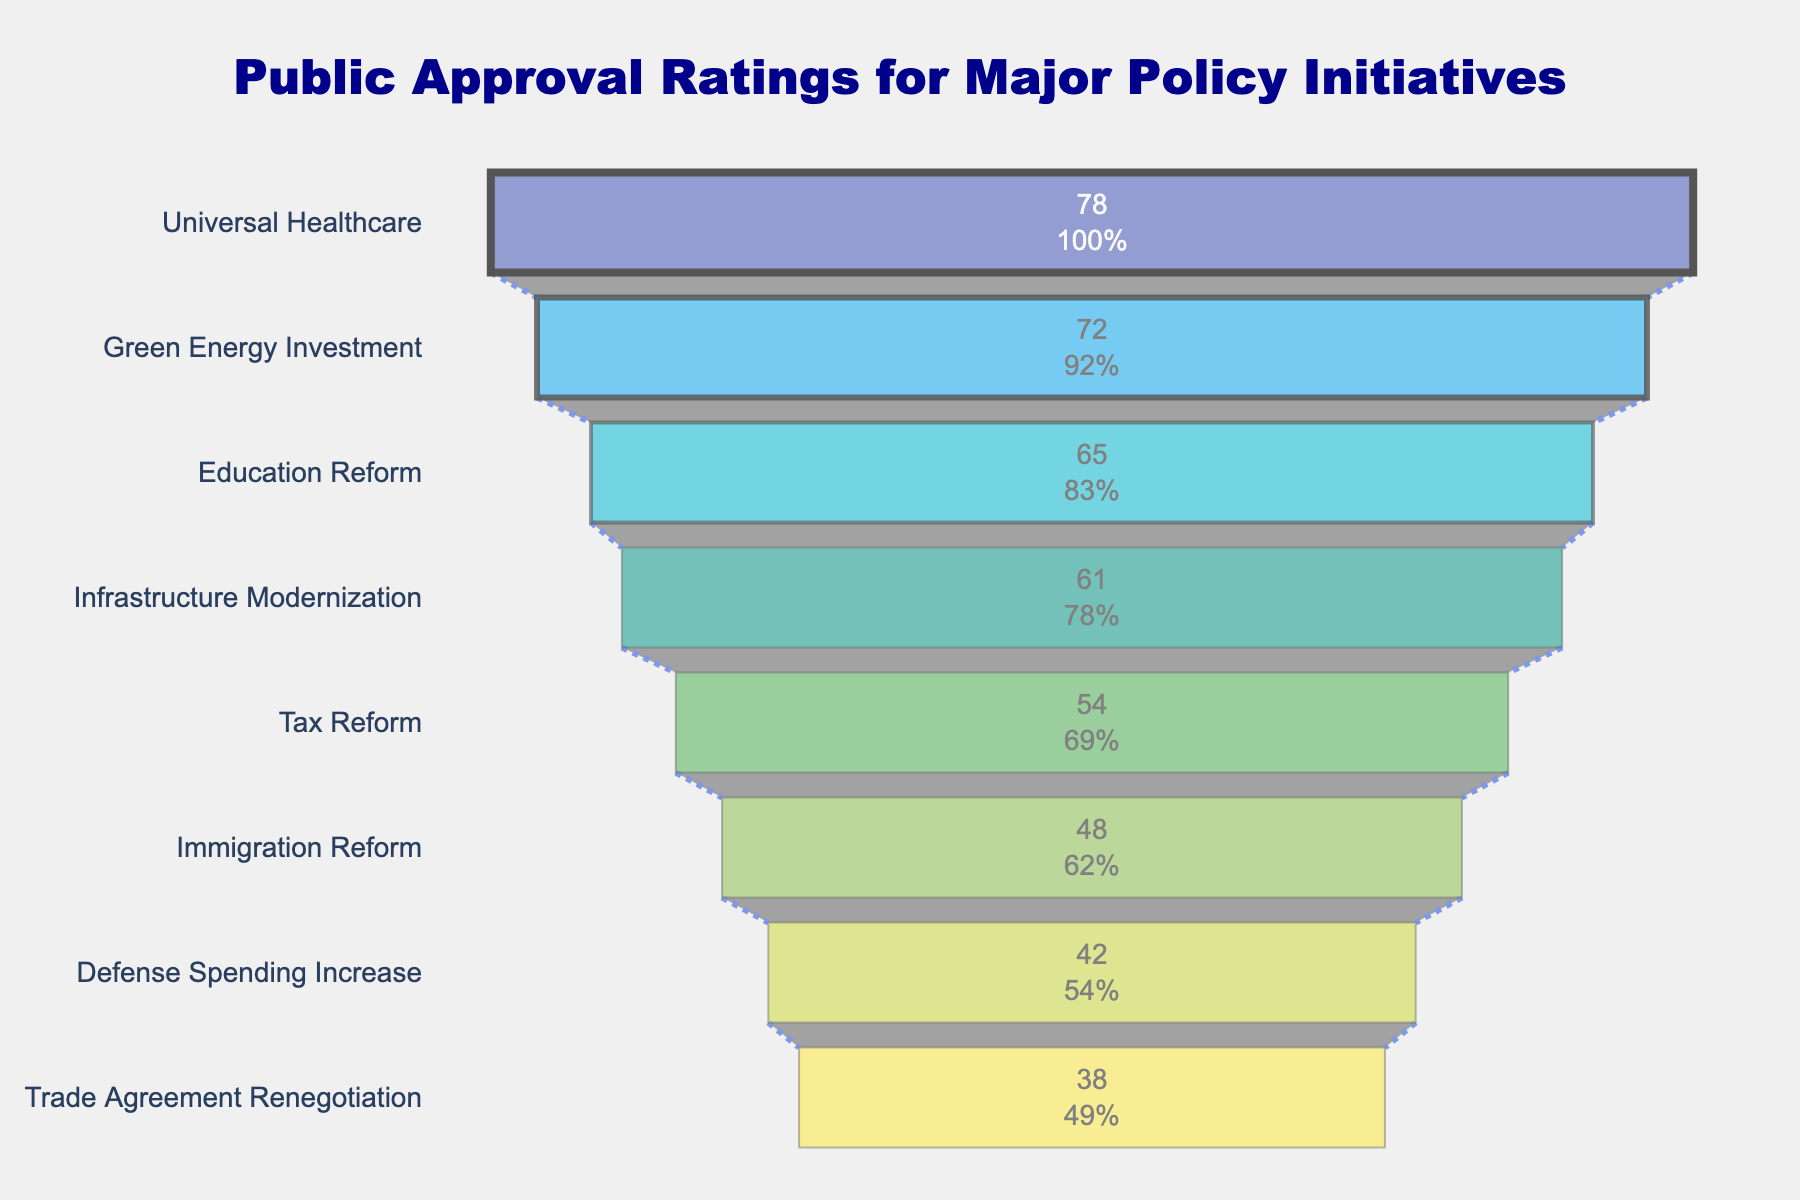What is the title of the chart? The title is located at the top center of the chart. It reads "Public Approval Ratings for Major Policy Initiatives".
Answer: Public Approval Ratings for Major Policy Initiatives Which policy has the highest approval rating? The funnel chart displays policies in descending order starting from the top. The top position represents the highest approval rating. The policy at the top is "Universal Healthcare".
Answer: Universal Healthcare What is the approval rating for Education Reform? Locate "Education Reform" on the y-axis. The corresponding bar shows the approval rating as 65%.
Answer: 65% How many policy initiatives have an approval rating of 50% or higher? Count the number of bars with approval ratings of 50% or higher by examining the x-axis values. The policies are Universal Healthcare, Green Energy Investment, Education Reform, Infrastructure Modernization, and Tax Reform.
Answer: 5 What is the difference in approval ratings between the most popular and least popular policy initiatives? The most popular policy is "Universal Healthcare" (78%), and the least popular is "Trade Agreement Renegotiation" (38%). Subtract the smallest percentage from the largest. 78% - 38% = 40%.
Answer: 40% Which policy has the lowest approval rating? The policy at the bottom of the funnel chart represents the lowest approval rating. This policy is "Trade Agreement Renegotiation".
Answer: Trade Agreement Renegotiation Which policies have approval ratings within 10% of each other? Identify policies whose approval ratings fall within a 10% range of each other. "Education Reform" (65%) and "Infrastructure Modernization" (61%) are within 10%. Also, "Immigration Reform" (48%) and "Defense Spending Increase" (42%) are within 10%.
Answer: Education Reform and Infrastructure Modernization, Immigration Reform and Defense Spending Increase What can you infer about the level of public support for Green Energy Investment compared to Tax Reform? Green Energy Investment has a higher approval rating than Tax Reform by examining their positions in the funnel: 72% for Green Energy Investment versus 54% for Tax Reform.
Answer: Green Energy Investment has more support than Tax Reform If the approval rating for Immigration Reform increased by 10%, where would it stand relative to other policies? Immigration Reform's current approval rating is 48%. With a 10% increase, it would be 58%. It would place between Tax Reform (54%) and Infrastructure Modernization (61%).
Answer: Between Tax Reform and Infrastructure Modernization What percentage of policies have approval ratings of below 50%? There are 8 policies in total. Policies with less than 50% approval are Immigration Reform, Defense Spending Increase, and Trade Agreement Renegotiation—3 out of 8 policies. Calculate 3/8 * 100 = 37.5%.
Answer: 37.5% 